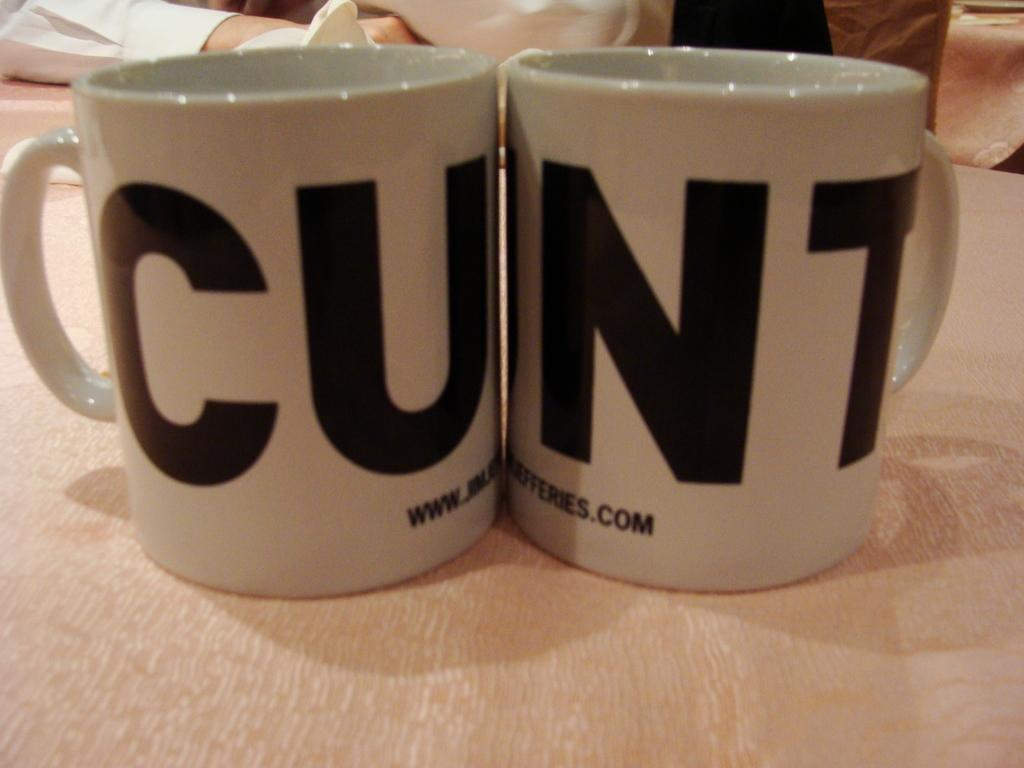<image>
Create a compact narrative representing the image presented. Two mugs sit together the first with the letters CU on it. 